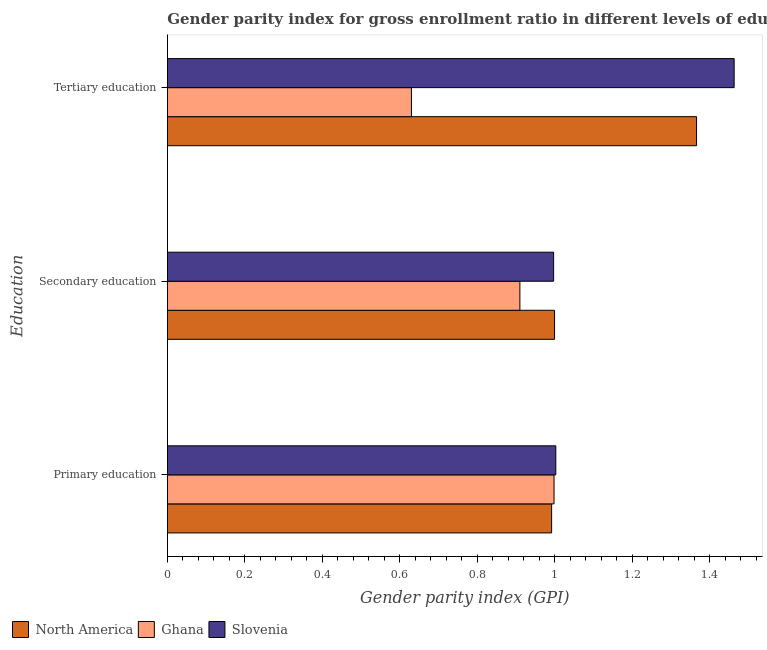Are the number of bars per tick equal to the number of legend labels?
Offer a very short reply. Yes. What is the label of the 2nd group of bars from the top?
Your answer should be very brief. Secondary education. What is the gender parity index in secondary education in Ghana?
Provide a succinct answer. 0.91. Across all countries, what is the maximum gender parity index in primary education?
Offer a terse response. 1. Across all countries, what is the minimum gender parity index in primary education?
Give a very brief answer. 0.99. In which country was the gender parity index in secondary education minimum?
Make the answer very short. Ghana. What is the total gender parity index in tertiary education in the graph?
Offer a terse response. 3.46. What is the difference between the gender parity index in primary education in Slovenia and that in North America?
Your response must be concise. 0.01. What is the difference between the gender parity index in primary education in North America and the gender parity index in tertiary education in Ghana?
Make the answer very short. 0.36. What is the average gender parity index in tertiary education per country?
Your answer should be compact. 1.15. What is the difference between the gender parity index in primary education and gender parity index in secondary education in Slovenia?
Offer a terse response. 0.01. What is the ratio of the gender parity index in secondary education in Slovenia to that in Ghana?
Provide a short and direct response. 1.1. Is the difference between the gender parity index in primary education in North America and Ghana greater than the difference between the gender parity index in tertiary education in North America and Ghana?
Offer a very short reply. No. What is the difference between the highest and the second highest gender parity index in secondary education?
Offer a terse response. 0. What is the difference between the highest and the lowest gender parity index in secondary education?
Make the answer very short. 0.09. Is the sum of the gender parity index in primary education in Ghana and Slovenia greater than the maximum gender parity index in secondary education across all countries?
Keep it short and to the point. Yes. What does the 1st bar from the top in Tertiary education represents?
Provide a succinct answer. Slovenia. Is it the case that in every country, the sum of the gender parity index in primary education and gender parity index in secondary education is greater than the gender parity index in tertiary education?
Provide a short and direct response. Yes. How many countries are there in the graph?
Make the answer very short. 3. What is the difference between two consecutive major ticks on the X-axis?
Your response must be concise. 0.2. Are the values on the major ticks of X-axis written in scientific E-notation?
Provide a short and direct response. No. Where does the legend appear in the graph?
Offer a terse response. Bottom left. What is the title of the graph?
Offer a very short reply. Gender parity index for gross enrollment ratio in different levels of education in 2013. Does "Hungary" appear as one of the legend labels in the graph?
Provide a succinct answer. No. What is the label or title of the X-axis?
Ensure brevity in your answer.  Gender parity index (GPI). What is the label or title of the Y-axis?
Ensure brevity in your answer.  Education. What is the Gender parity index (GPI) of North America in Primary education?
Offer a terse response. 0.99. What is the Gender parity index (GPI) in Ghana in Primary education?
Your answer should be very brief. 1. What is the Gender parity index (GPI) in Slovenia in Primary education?
Your response must be concise. 1. What is the Gender parity index (GPI) of North America in Secondary education?
Keep it short and to the point. 1. What is the Gender parity index (GPI) in Ghana in Secondary education?
Keep it short and to the point. 0.91. What is the Gender parity index (GPI) of Slovenia in Secondary education?
Make the answer very short. 1. What is the Gender parity index (GPI) of North America in Tertiary education?
Offer a terse response. 1.37. What is the Gender parity index (GPI) in Ghana in Tertiary education?
Keep it short and to the point. 0.63. What is the Gender parity index (GPI) of Slovenia in Tertiary education?
Your response must be concise. 1.46. Across all Education, what is the maximum Gender parity index (GPI) in North America?
Ensure brevity in your answer.  1.37. Across all Education, what is the maximum Gender parity index (GPI) in Ghana?
Give a very brief answer. 1. Across all Education, what is the maximum Gender parity index (GPI) in Slovenia?
Make the answer very short. 1.46. Across all Education, what is the minimum Gender parity index (GPI) in North America?
Give a very brief answer. 0.99. Across all Education, what is the minimum Gender parity index (GPI) of Ghana?
Keep it short and to the point. 0.63. Across all Education, what is the minimum Gender parity index (GPI) in Slovenia?
Give a very brief answer. 1. What is the total Gender parity index (GPI) in North America in the graph?
Offer a terse response. 3.36. What is the total Gender parity index (GPI) in Ghana in the graph?
Provide a succinct answer. 2.54. What is the total Gender parity index (GPI) of Slovenia in the graph?
Your answer should be very brief. 3.46. What is the difference between the Gender parity index (GPI) of North America in Primary education and that in Secondary education?
Provide a succinct answer. -0.01. What is the difference between the Gender parity index (GPI) in Ghana in Primary education and that in Secondary education?
Make the answer very short. 0.09. What is the difference between the Gender parity index (GPI) of Slovenia in Primary education and that in Secondary education?
Provide a succinct answer. 0.01. What is the difference between the Gender parity index (GPI) of North America in Primary education and that in Tertiary education?
Your response must be concise. -0.37. What is the difference between the Gender parity index (GPI) in Ghana in Primary education and that in Tertiary education?
Your answer should be compact. 0.37. What is the difference between the Gender parity index (GPI) of Slovenia in Primary education and that in Tertiary education?
Ensure brevity in your answer.  -0.46. What is the difference between the Gender parity index (GPI) of North America in Secondary education and that in Tertiary education?
Give a very brief answer. -0.37. What is the difference between the Gender parity index (GPI) of Ghana in Secondary education and that in Tertiary education?
Ensure brevity in your answer.  0.28. What is the difference between the Gender parity index (GPI) in Slovenia in Secondary education and that in Tertiary education?
Give a very brief answer. -0.47. What is the difference between the Gender parity index (GPI) of North America in Primary education and the Gender parity index (GPI) of Ghana in Secondary education?
Provide a succinct answer. 0.08. What is the difference between the Gender parity index (GPI) in North America in Primary education and the Gender parity index (GPI) in Slovenia in Secondary education?
Provide a succinct answer. -0.01. What is the difference between the Gender parity index (GPI) of Ghana in Primary education and the Gender parity index (GPI) of Slovenia in Secondary education?
Provide a short and direct response. 0. What is the difference between the Gender parity index (GPI) of North America in Primary education and the Gender parity index (GPI) of Ghana in Tertiary education?
Your answer should be compact. 0.36. What is the difference between the Gender parity index (GPI) in North America in Primary education and the Gender parity index (GPI) in Slovenia in Tertiary education?
Give a very brief answer. -0.47. What is the difference between the Gender parity index (GPI) in Ghana in Primary education and the Gender parity index (GPI) in Slovenia in Tertiary education?
Give a very brief answer. -0.46. What is the difference between the Gender parity index (GPI) of North America in Secondary education and the Gender parity index (GPI) of Ghana in Tertiary education?
Your answer should be very brief. 0.37. What is the difference between the Gender parity index (GPI) in North America in Secondary education and the Gender parity index (GPI) in Slovenia in Tertiary education?
Your answer should be very brief. -0.46. What is the difference between the Gender parity index (GPI) of Ghana in Secondary education and the Gender parity index (GPI) of Slovenia in Tertiary education?
Keep it short and to the point. -0.55. What is the average Gender parity index (GPI) of North America per Education?
Give a very brief answer. 1.12. What is the average Gender parity index (GPI) in Ghana per Education?
Offer a terse response. 0.85. What is the average Gender parity index (GPI) in Slovenia per Education?
Offer a very short reply. 1.15. What is the difference between the Gender parity index (GPI) of North America and Gender parity index (GPI) of Ghana in Primary education?
Offer a terse response. -0.01. What is the difference between the Gender parity index (GPI) of North America and Gender parity index (GPI) of Slovenia in Primary education?
Provide a short and direct response. -0.01. What is the difference between the Gender parity index (GPI) of Ghana and Gender parity index (GPI) of Slovenia in Primary education?
Offer a terse response. -0. What is the difference between the Gender parity index (GPI) of North America and Gender parity index (GPI) of Ghana in Secondary education?
Make the answer very short. 0.09. What is the difference between the Gender parity index (GPI) of North America and Gender parity index (GPI) of Slovenia in Secondary education?
Provide a succinct answer. 0. What is the difference between the Gender parity index (GPI) in Ghana and Gender parity index (GPI) in Slovenia in Secondary education?
Provide a succinct answer. -0.09. What is the difference between the Gender parity index (GPI) of North America and Gender parity index (GPI) of Ghana in Tertiary education?
Your response must be concise. 0.74. What is the difference between the Gender parity index (GPI) of North America and Gender parity index (GPI) of Slovenia in Tertiary education?
Offer a terse response. -0.1. What is the difference between the Gender parity index (GPI) of Ghana and Gender parity index (GPI) of Slovenia in Tertiary education?
Make the answer very short. -0.83. What is the ratio of the Gender parity index (GPI) in Ghana in Primary education to that in Secondary education?
Your answer should be very brief. 1.1. What is the ratio of the Gender parity index (GPI) of Slovenia in Primary education to that in Secondary education?
Give a very brief answer. 1.01. What is the ratio of the Gender parity index (GPI) in North America in Primary education to that in Tertiary education?
Offer a terse response. 0.73. What is the ratio of the Gender parity index (GPI) in Ghana in Primary education to that in Tertiary education?
Keep it short and to the point. 1.58. What is the ratio of the Gender parity index (GPI) in Slovenia in Primary education to that in Tertiary education?
Your answer should be very brief. 0.69. What is the ratio of the Gender parity index (GPI) in North America in Secondary education to that in Tertiary education?
Make the answer very short. 0.73. What is the ratio of the Gender parity index (GPI) in Ghana in Secondary education to that in Tertiary education?
Provide a succinct answer. 1.44. What is the ratio of the Gender parity index (GPI) of Slovenia in Secondary education to that in Tertiary education?
Provide a succinct answer. 0.68. What is the difference between the highest and the second highest Gender parity index (GPI) in North America?
Your answer should be very brief. 0.37. What is the difference between the highest and the second highest Gender parity index (GPI) of Ghana?
Keep it short and to the point. 0.09. What is the difference between the highest and the second highest Gender parity index (GPI) of Slovenia?
Your answer should be compact. 0.46. What is the difference between the highest and the lowest Gender parity index (GPI) of North America?
Your answer should be very brief. 0.37. What is the difference between the highest and the lowest Gender parity index (GPI) in Ghana?
Your response must be concise. 0.37. What is the difference between the highest and the lowest Gender parity index (GPI) in Slovenia?
Your answer should be very brief. 0.47. 